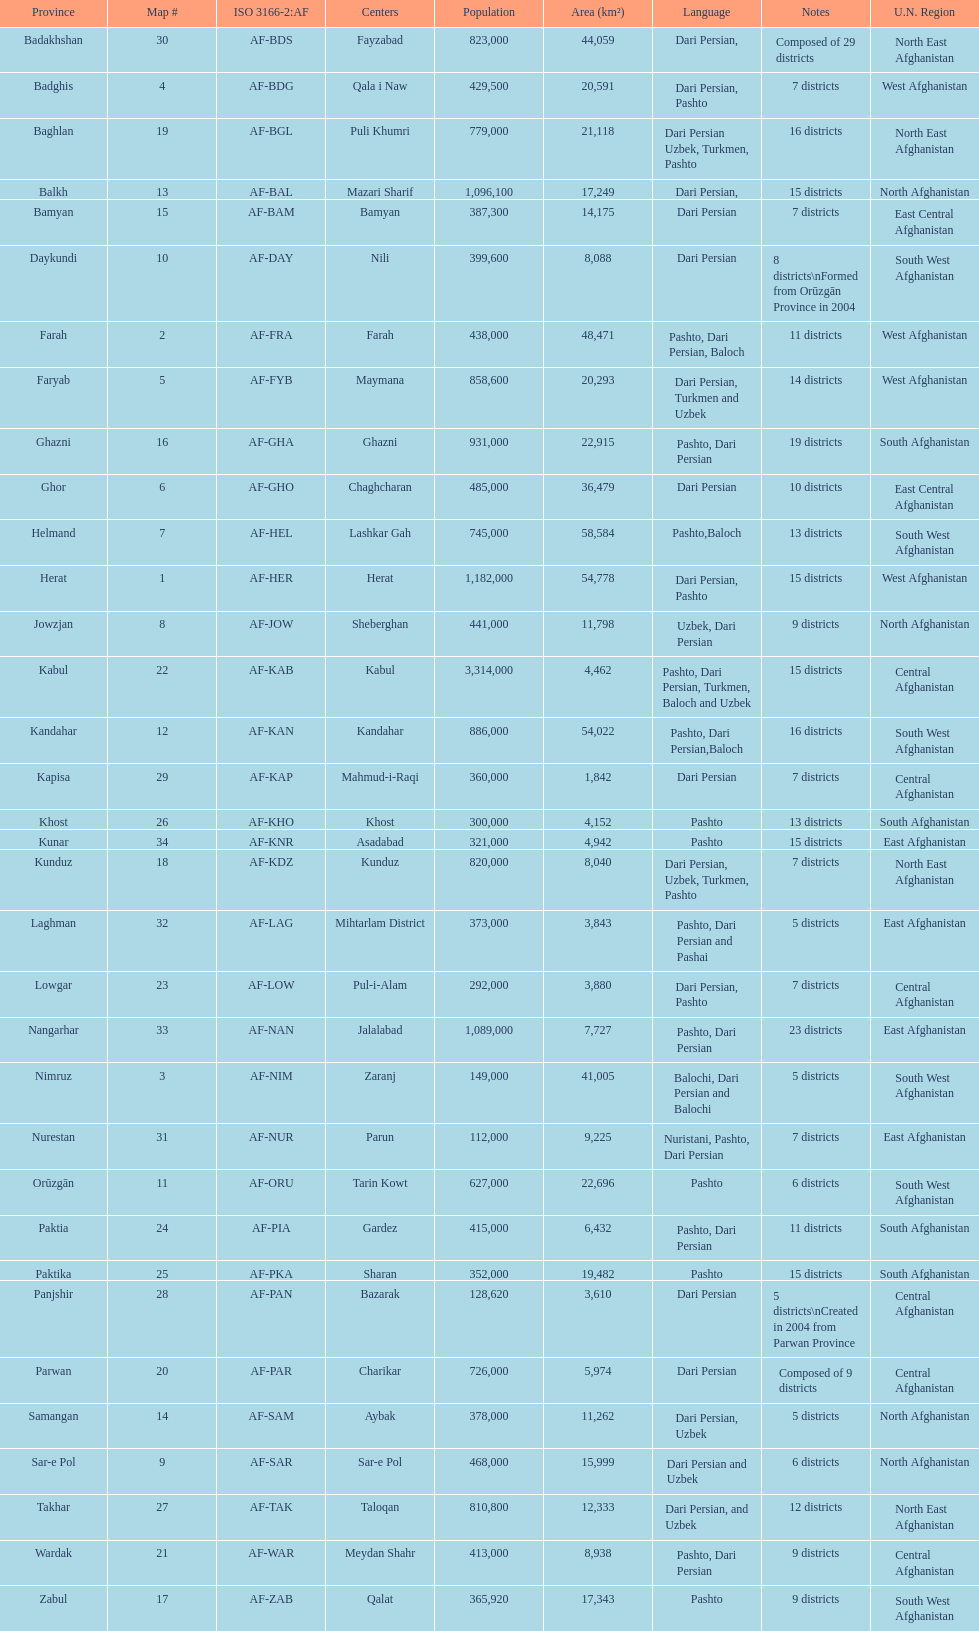How many districts are in the province of kunduz? 7. 